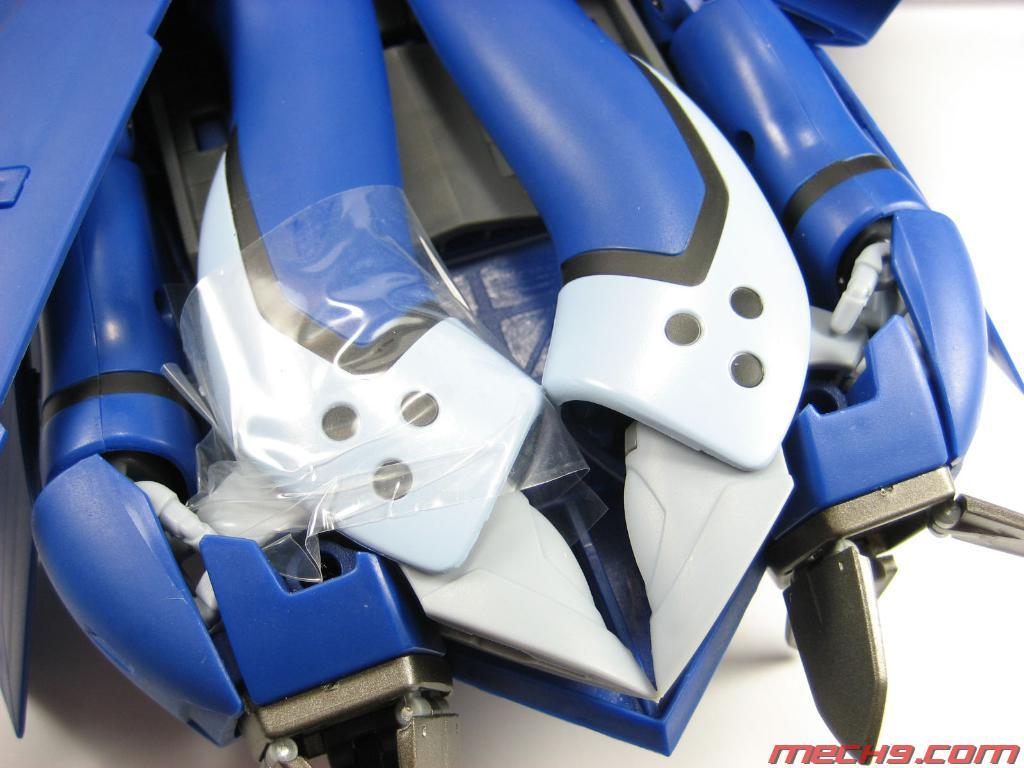What is the main subject in the image? There is a blue color toy in the image. What is the color of the toy? The blue color toy is placed on a white surface. What day of the week is depicted in the image? There is no indication of a specific day of the week in the image. Can you tell me how many windows are visible in the image? There is no window present in the image; it only features a blue color toy on a white surface. 